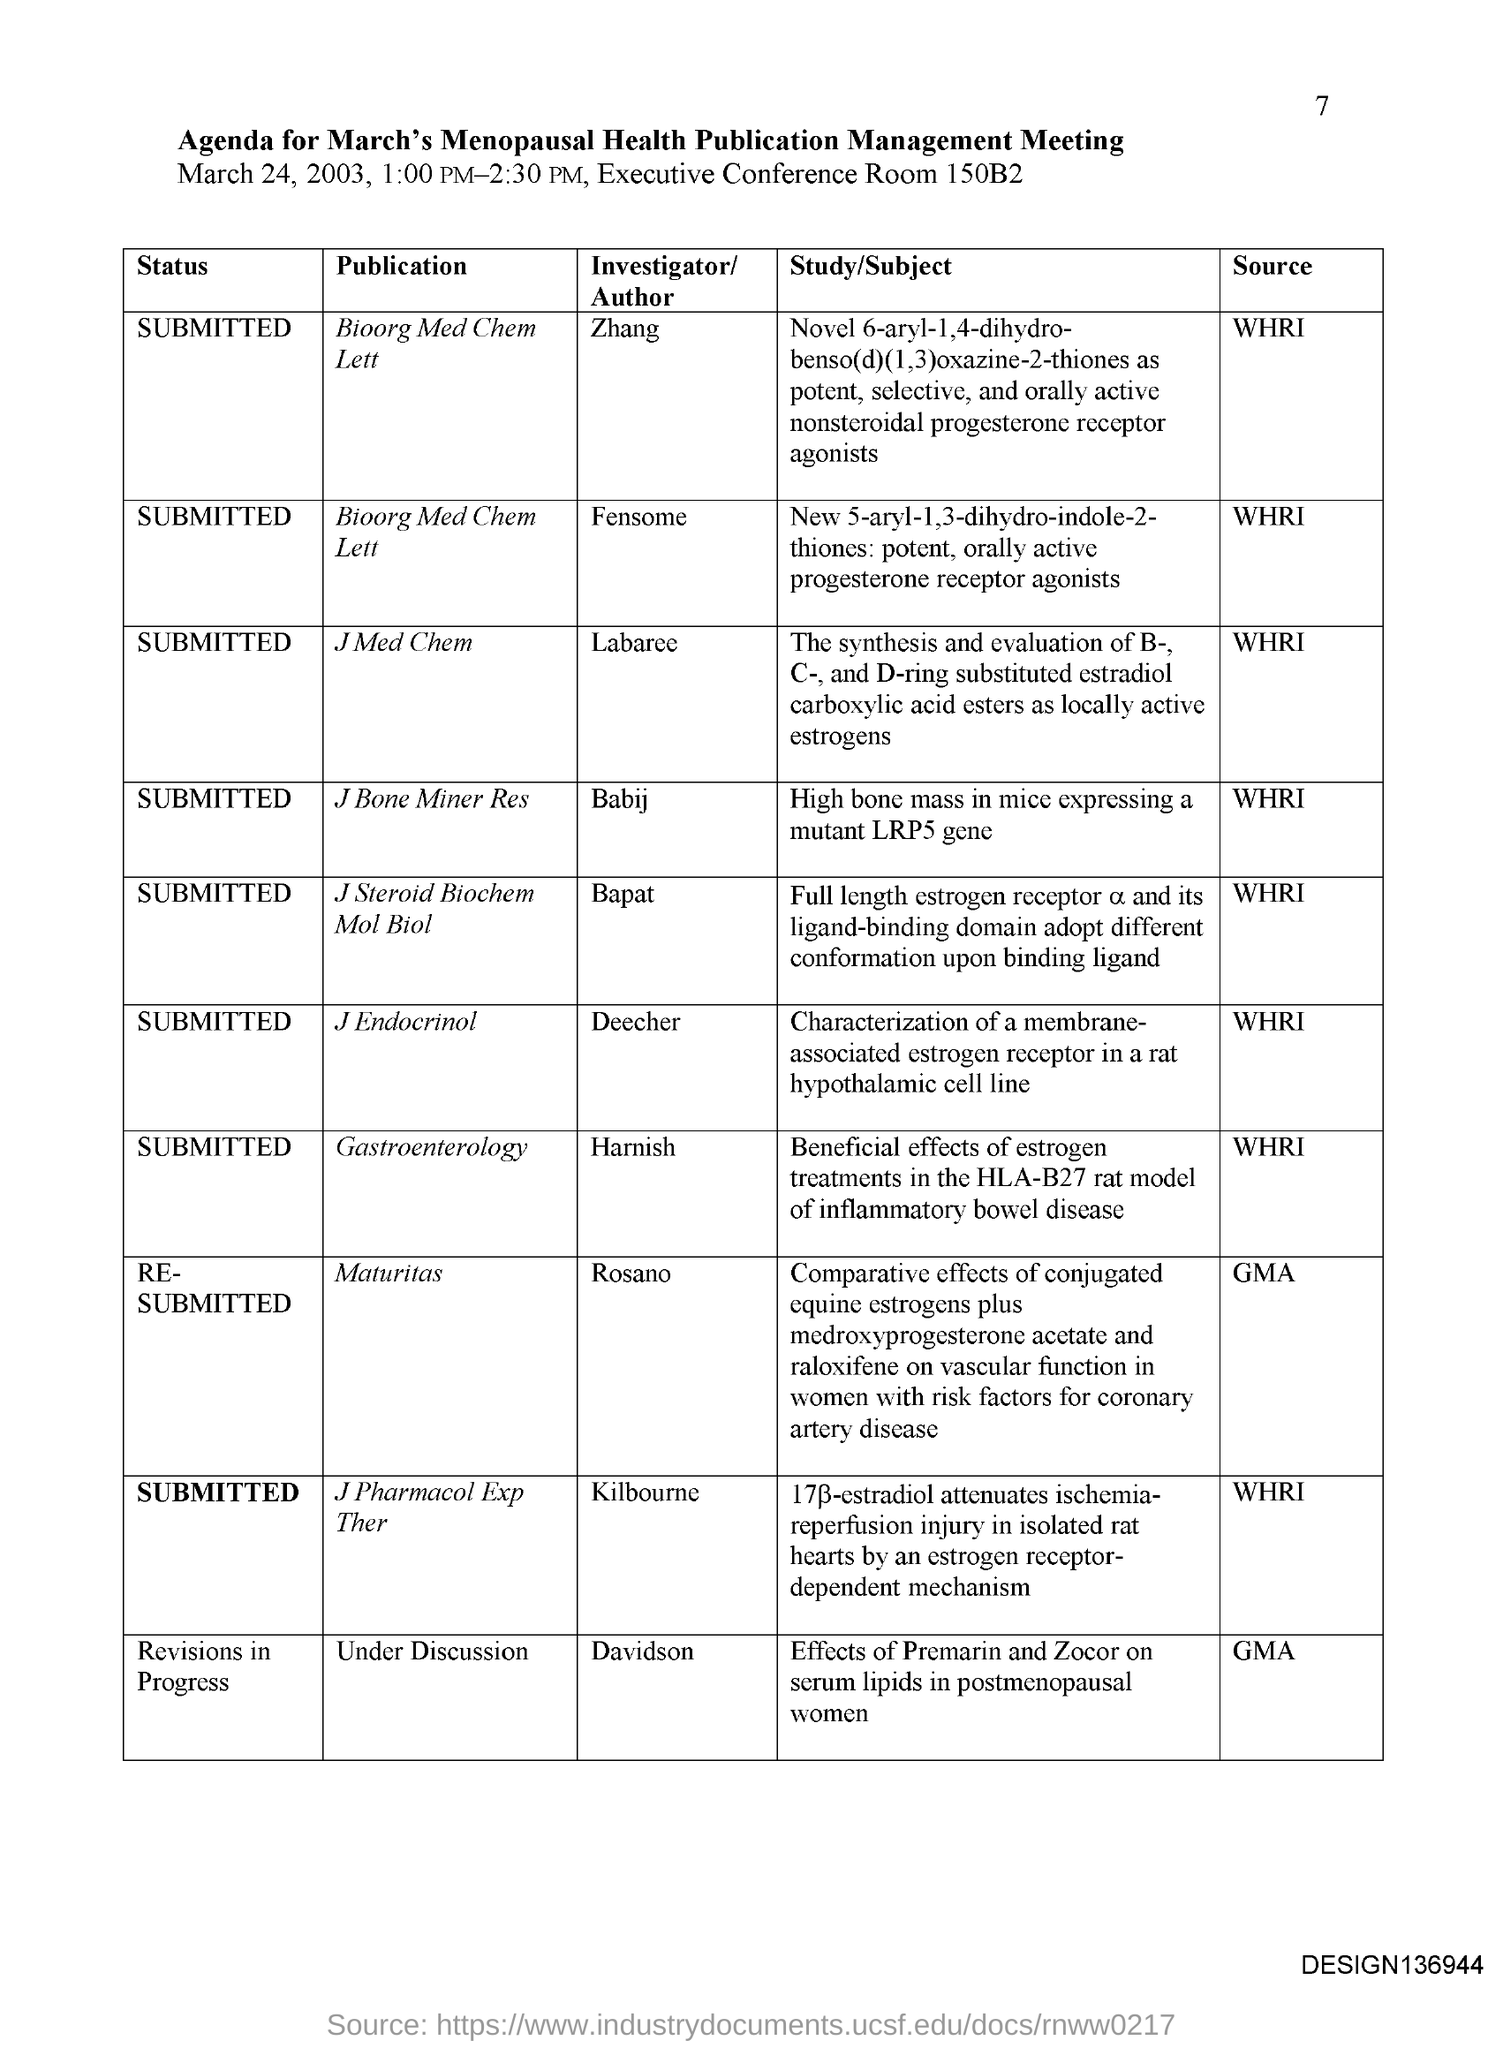Are there any clinical applications mentioned in the listed studies? Based on the document, clinical applications can be inferred in several of the studies. For instance, the research on the effects of conjugated equine estrogens and raloxifene on vascular function in women indicates direct clinical relevance, potentially aiming at improving treatment options for coronary artery disease in postmenopausal women. Similarly, the study discussing the attenuation of ischemia-reperfusion injury points towards potential therapeutic interventions for heart conditions. 